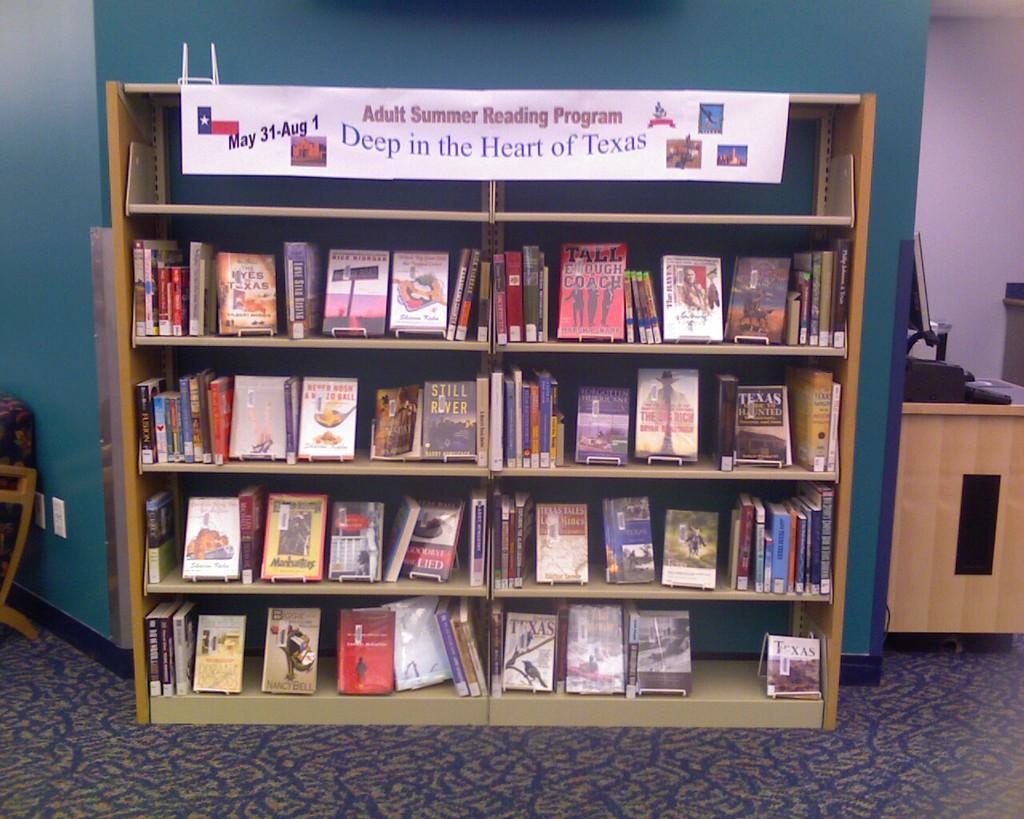How would you summarize this image in a sentence or two? In the picture we can see a book rack with full of books in it and some poster on the top of it and written something on it and behind it, we can see a wall which is blue in color and beside it, we can see a desk with monitor and on the other side, we can see a part of the chair and on the floor we can see a floor mat which is blue in color with designs on it. 